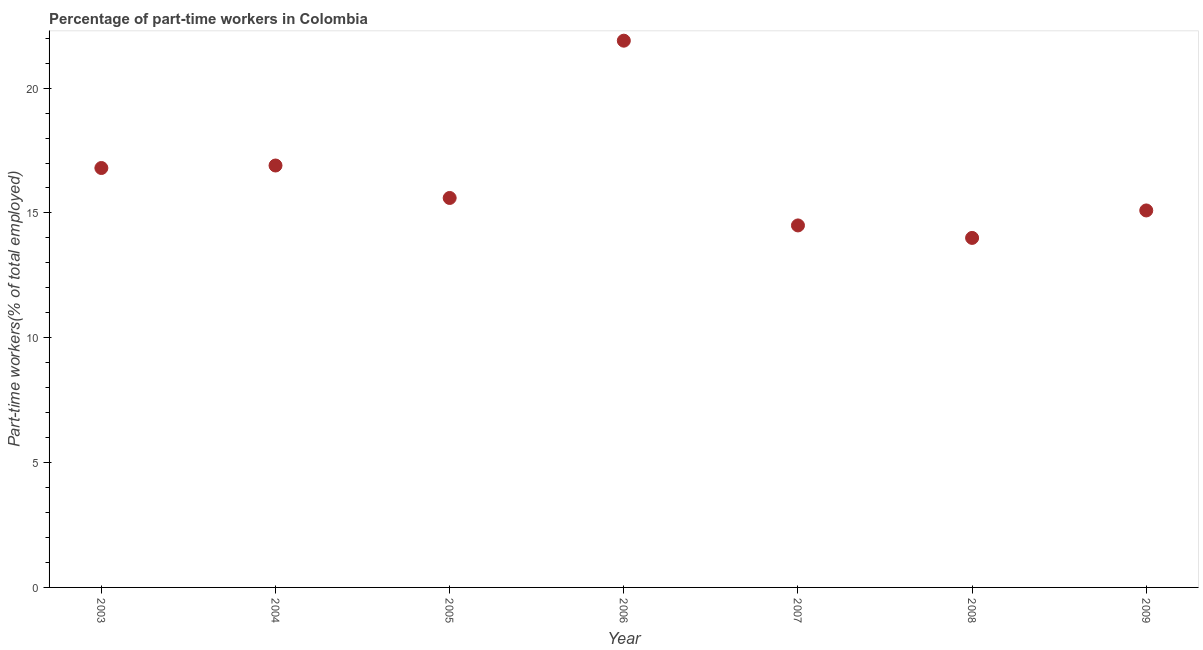What is the percentage of part-time workers in 2004?
Your answer should be very brief. 16.9. Across all years, what is the maximum percentage of part-time workers?
Your answer should be very brief. 21.9. In which year was the percentage of part-time workers minimum?
Make the answer very short. 2008. What is the sum of the percentage of part-time workers?
Offer a very short reply. 114.8. What is the difference between the percentage of part-time workers in 2005 and 2006?
Provide a short and direct response. -6.3. What is the average percentage of part-time workers per year?
Your answer should be compact. 16.4. What is the median percentage of part-time workers?
Keep it short and to the point. 15.6. In how many years, is the percentage of part-time workers greater than 4 %?
Offer a terse response. 7. Do a majority of the years between 2009 and 2008 (inclusive) have percentage of part-time workers greater than 21 %?
Offer a very short reply. No. What is the ratio of the percentage of part-time workers in 2003 to that in 2008?
Ensure brevity in your answer.  1.2. Is the percentage of part-time workers in 2005 less than that in 2006?
Keep it short and to the point. Yes. What is the difference between the highest and the second highest percentage of part-time workers?
Your response must be concise. 5. Is the sum of the percentage of part-time workers in 2005 and 2007 greater than the maximum percentage of part-time workers across all years?
Offer a terse response. Yes. What is the difference between the highest and the lowest percentage of part-time workers?
Offer a terse response. 7.9. Does the percentage of part-time workers monotonically increase over the years?
Make the answer very short. No. How many dotlines are there?
Your answer should be very brief. 1. How many years are there in the graph?
Make the answer very short. 7. What is the difference between two consecutive major ticks on the Y-axis?
Provide a succinct answer. 5. What is the title of the graph?
Make the answer very short. Percentage of part-time workers in Colombia. What is the label or title of the Y-axis?
Provide a succinct answer. Part-time workers(% of total employed). What is the Part-time workers(% of total employed) in 2003?
Your answer should be compact. 16.8. What is the Part-time workers(% of total employed) in 2004?
Provide a short and direct response. 16.9. What is the Part-time workers(% of total employed) in 2005?
Provide a short and direct response. 15.6. What is the Part-time workers(% of total employed) in 2006?
Make the answer very short. 21.9. What is the Part-time workers(% of total employed) in 2008?
Offer a very short reply. 14. What is the Part-time workers(% of total employed) in 2009?
Your answer should be compact. 15.1. What is the difference between the Part-time workers(% of total employed) in 2003 and 2005?
Make the answer very short. 1.2. What is the difference between the Part-time workers(% of total employed) in 2003 and 2008?
Your answer should be very brief. 2.8. What is the difference between the Part-time workers(% of total employed) in 2003 and 2009?
Offer a very short reply. 1.7. What is the difference between the Part-time workers(% of total employed) in 2004 and 2008?
Your answer should be compact. 2.9. What is the difference between the Part-time workers(% of total employed) in 2005 and 2006?
Offer a very short reply. -6.3. What is the difference between the Part-time workers(% of total employed) in 2005 and 2008?
Make the answer very short. 1.6. What is the difference between the Part-time workers(% of total employed) in 2005 and 2009?
Your response must be concise. 0.5. What is the difference between the Part-time workers(% of total employed) in 2006 and 2007?
Make the answer very short. 7.4. What is the difference between the Part-time workers(% of total employed) in 2007 and 2008?
Make the answer very short. 0.5. What is the difference between the Part-time workers(% of total employed) in 2007 and 2009?
Ensure brevity in your answer.  -0.6. What is the difference between the Part-time workers(% of total employed) in 2008 and 2009?
Provide a short and direct response. -1.1. What is the ratio of the Part-time workers(% of total employed) in 2003 to that in 2005?
Your answer should be compact. 1.08. What is the ratio of the Part-time workers(% of total employed) in 2003 to that in 2006?
Your answer should be compact. 0.77. What is the ratio of the Part-time workers(% of total employed) in 2003 to that in 2007?
Offer a very short reply. 1.16. What is the ratio of the Part-time workers(% of total employed) in 2003 to that in 2009?
Your answer should be very brief. 1.11. What is the ratio of the Part-time workers(% of total employed) in 2004 to that in 2005?
Ensure brevity in your answer.  1.08. What is the ratio of the Part-time workers(% of total employed) in 2004 to that in 2006?
Offer a very short reply. 0.77. What is the ratio of the Part-time workers(% of total employed) in 2004 to that in 2007?
Provide a short and direct response. 1.17. What is the ratio of the Part-time workers(% of total employed) in 2004 to that in 2008?
Your answer should be very brief. 1.21. What is the ratio of the Part-time workers(% of total employed) in 2004 to that in 2009?
Your response must be concise. 1.12. What is the ratio of the Part-time workers(% of total employed) in 2005 to that in 2006?
Offer a very short reply. 0.71. What is the ratio of the Part-time workers(% of total employed) in 2005 to that in 2007?
Give a very brief answer. 1.08. What is the ratio of the Part-time workers(% of total employed) in 2005 to that in 2008?
Offer a very short reply. 1.11. What is the ratio of the Part-time workers(% of total employed) in 2005 to that in 2009?
Your answer should be very brief. 1.03. What is the ratio of the Part-time workers(% of total employed) in 2006 to that in 2007?
Provide a short and direct response. 1.51. What is the ratio of the Part-time workers(% of total employed) in 2006 to that in 2008?
Your response must be concise. 1.56. What is the ratio of the Part-time workers(% of total employed) in 2006 to that in 2009?
Offer a very short reply. 1.45. What is the ratio of the Part-time workers(% of total employed) in 2007 to that in 2008?
Provide a succinct answer. 1.04. What is the ratio of the Part-time workers(% of total employed) in 2007 to that in 2009?
Offer a terse response. 0.96. What is the ratio of the Part-time workers(% of total employed) in 2008 to that in 2009?
Provide a succinct answer. 0.93. 